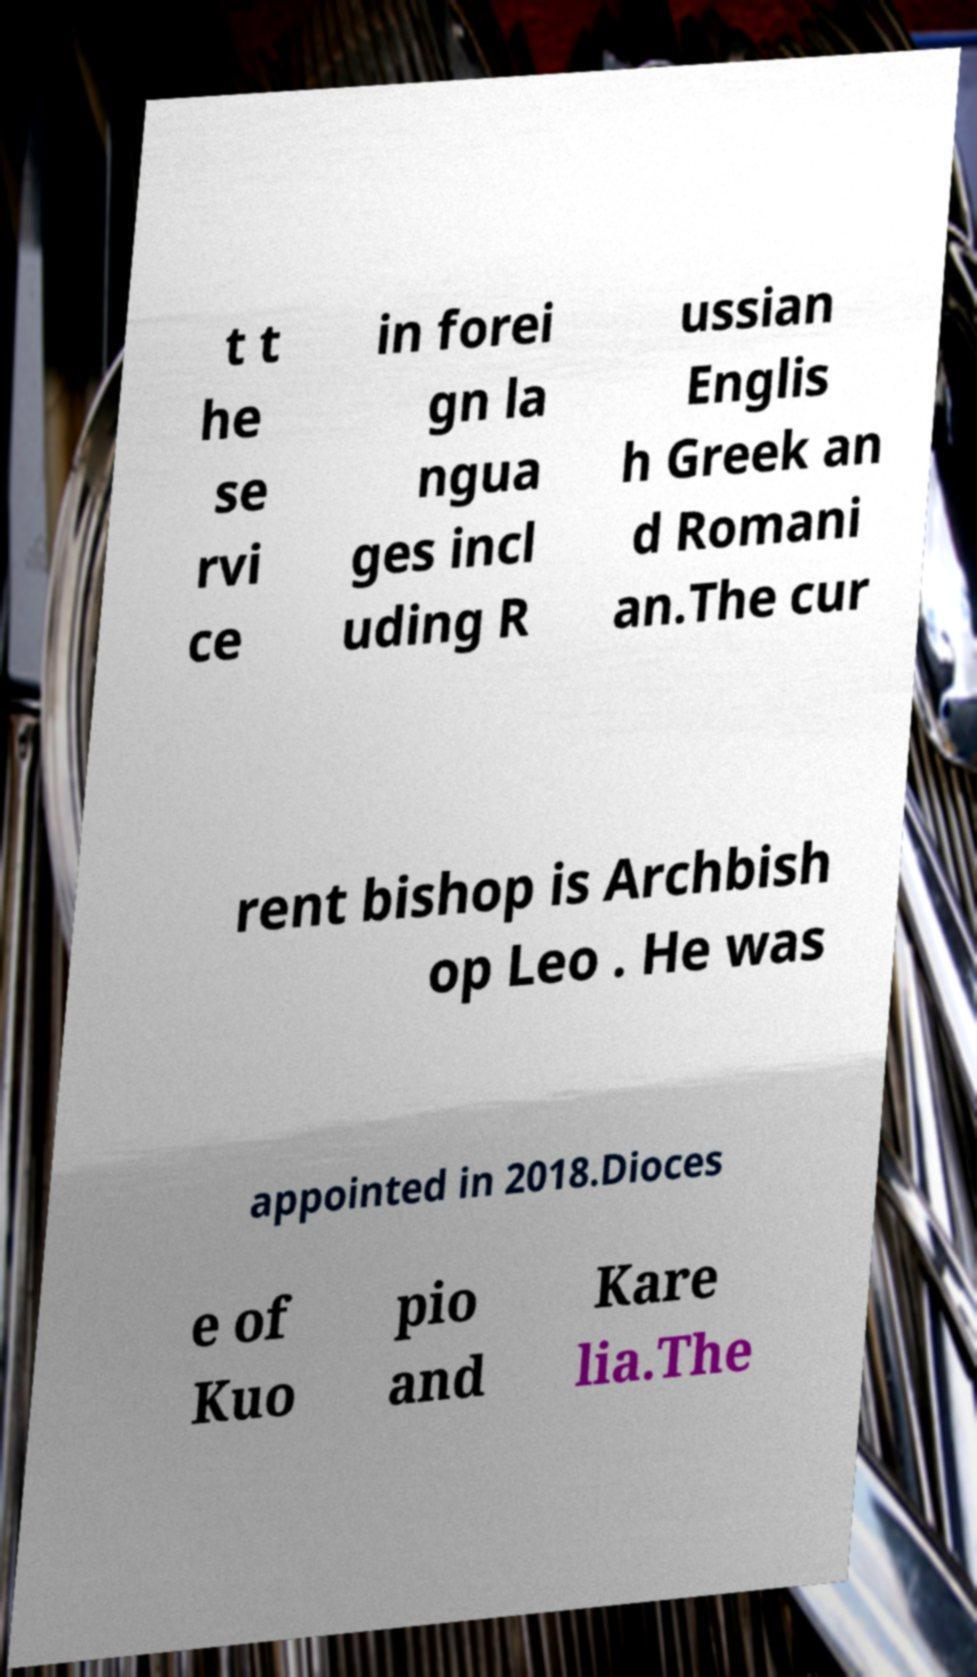Please read and relay the text visible in this image. What does it say? t t he se rvi ce in forei gn la ngua ges incl uding R ussian Englis h Greek an d Romani an.The cur rent bishop is Archbish op Leo . He was appointed in 2018.Dioces e of Kuo pio and Kare lia.The 